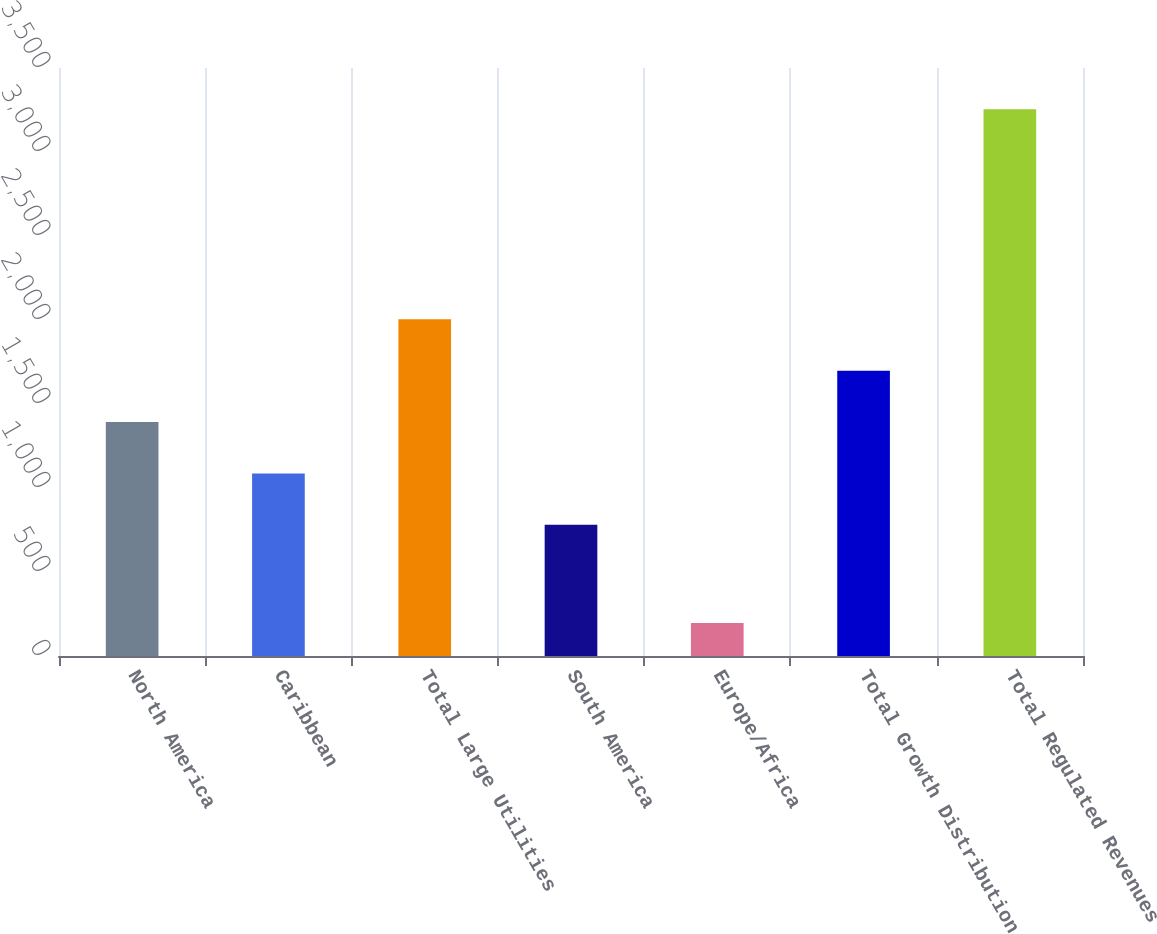<chart> <loc_0><loc_0><loc_500><loc_500><bar_chart><fcel>North America<fcel>Caribbean<fcel>Total Large Utilities<fcel>South America<fcel>Europe/Africa<fcel>Total Growth Distribution<fcel>Total Regulated Revenues<nl><fcel>1392.6<fcel>1086.8<fcel>2004.2<fcel>781<fcel>197<fcel>1698.4<fcel>3255<nl></chart> 